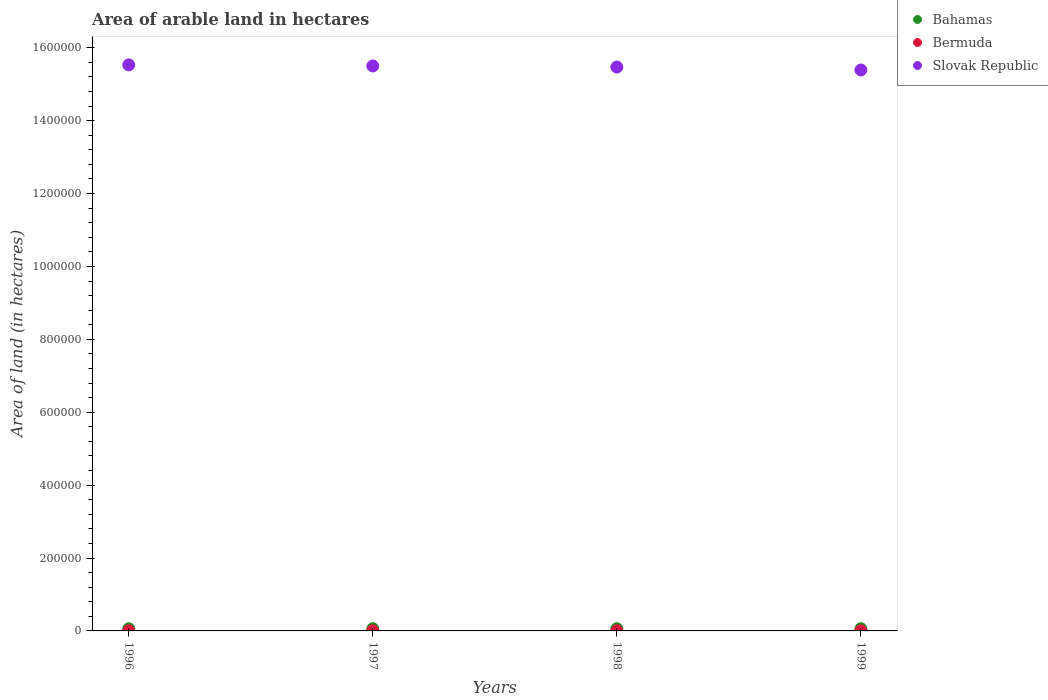What is the total arable land in Bermuda in 1998?
Provide a succinct answer. 400. Across all years, what is the maximum total arable land in Slovak Republic?
Your answer should be compact. 1.55e+06. Across all years, what is the minimum total arable land in Bermuda?
Provide a succinct answer. 400. In which year was the total arable land in Bermuda minimum?
Offer a terse response. 1996. What is the total total arable land in Slovak Republic in the graph?
Provide a succinct answer. 6.19e+06. What is the difference between the total arable land in Slovak Republic in 1996 and that in 1999?
Your answer should be very brief. 1.40e+04. What is the difference between the total arable land in Slovak Republic in 1999 and the total arable land in Bermuda in 1996?
Make the answer very short. 1.54e+06. What is the average total arable land in Bahamas per year?
Provide a short and direct response. 6000. In the year 1997, what is the difference between the total arable land in Slovak Republic and total arable land in Bermuda?
Give a very brief answer. 1.55e+06. What is the ratio of the total arable land in Slovak Republic in 1996 to that in 1997?
Give a very brief answer. 1. Is the total arable land in Bahamas in 1996 less than that in 1999?
Provide a short and direct response. No. Is the difference between the total arable land in Slovak Republic in 1998 and 1999 greater than the difference between the total arable land in Bermuda in 1998 and 1999?
Your answer should be very brief. Yes. What is the difference between the highest and the lowest total arable land in Slovak Republic?
Provide a succinct answer. 1.40e+04. In how many years, is the total arable land in Slovak Republic greater than the average total arable land in Slovak Republic taken over all years?
Provide a short and direct response. 2. Is it the case that in every year, the sum of the total arable land in Bahamas and total arable land in Bermuda  is greater than the total arable land in Slovak Republic?
Your response must be concise. No. Does the total arable land in Bahamas monotonically increase over the years?
Keep it short and to the point. No. Is the total arable land in Bermuda strictly greater than the total arable land in Bahamas over the years?
Ensure brevity in your answer.  No. Is the total arable land in Slovak Republic strictly less than the total arable land in Bermuda over the years?
Make the answer very short. No. How many dotlines are there?
Your answer should be very brief. 3. How many years are there in the graph?
Provide a succinct answer. 4. What is the difference between two consecutive major ticks on the Y-axis?
Ensure brevity in your answer.  2.00e+05. Are the values on the major ticks of Y-axis written in scientific E-notation?
Your answer should be compact. No. Does the graph contain grids?
Your answer should be compact. No. Where does the legend appear in the graph?
Offer a very short reply. Top right. How are the legend labels stacked?
Provide a short and direct response. Vertical. What is the title of the graph?
Provide a succinct answer. Area of arable land in hectares. What is the label or title of the Y-axis?
Provide a short and direct response. Area of land (in hectares). What is the Area of land (in hectares) in Bahamas in 1996?
Provide a succinct answer. 6000. What is the Area of land (in hectares) of Bermuda in 1996?
Keep it short and to the point. 400. What is the Area of land (in hectares) of Slovak Republic in 1996?
Your answer should be compact. 1.55e+06. What is the Area of land (in hectares) of Bahamas in 1997?
Give a very brief answer. 6000. What is the Area of land (in hectares) in Slovak Republic in 1997?
Ensure brevity in your answer.  1.55e+06. What is the Area of land (in hectares) of Bahamas in 1998?
Keep it short and to the point. 6000. What is the Area of land (in hectares) in Slovak Republic in 1998?
Make the answer very short. 1.55e+06. What is the Area of land (in hectares) in Bahamas in 1999?
Keep it short and to the point. 6000. What is the Area of land (in hectares) in Slovak Republic in 1999?
Give a very brief answer. 1.54e+06. Across all years, what is the maximum Area of land (in hectares) of Bahamas?
Provide a succinct answer. 6000. Across all years, what is the maximum Area of land (in hectares) of Bermuda?
Your answer should be compact. 400. Across all years, what is the maximum Area of land (in hectares) of Slovak Republic?
Offer a terse response. 1.55e+06. Across all years, what is the minimum Area of land (in hectares) in Bahamas?
Offer a terse response. 6000. Across all years, what is the minimum Area of land (in hectares) of Bermuda?
Ensure brevity in your answer.  400. Across all years, what is the minimum Area of land (in hectares) of Slovak Republic?
Provide a succinct answer. 1.54e+06. What is the total Area of land (in hectares) of Bahamas in the graph?
Give a very brief answer. 2.40e+04. What is the total Area of land (in hectares) of Bermuda in the graph?
Provide a short and direct response. 1600. What is the total Area of land (in hectares) of Slovak Republic in the graph?
Make the answer very short. 6.19e+06. What is the difference between the Area of land (in hectares) of Bermuda in 1996 and that in 1997?
Provide a succinct answer. 0. What is the difference between the Area of land (in hectares) of Slovak Republic in 1996 and that in 1997?
Ensure brevity in your answer.  3000. What is the difference between the Area of land (in hectares) in Slovak Republic in 1996 and that in 1998?
Keep it short and to the point. 6000. What is the difference between the Area of land (in hectares) of Bermuda in 1996 and that in 1999?
Your response must be concise. 0. What is the difference between the Area of land (in hectares) in Slovak Republic in 1996 and that in 1999?
Offer a terse response. 1.40e+04. What is the difference between the Area of land (in hectares) in Bahamas in 1997 and that in 1998?
Ensure brevity in your answer.  0. What is the difference between the Area of land (in hectares) in Bermuda in 1997 and that in 1998?
Give a very brief answer. 0. What is the difference between the Area of land (in hectares) in Slovak Republic in 1997 and that in 1998?
Your answer should be compact. 3000. What is the difference between the Area of land (in hectares) of Bermuda in 1997 and that in 1999?
Offer a terse response. 0. What is the difference between the Area of land (in hectares) in Slovak Republic in 1997 and that in 1999?
Give a very brief answer. 1.10e+04. What is the difference between the Area of land (in hectares) in Bahamas in 1998 and that in 1999?
Offer a terse response. 0. What is the difference between the Area of land (in hectares) in Bermuda in 1998 and that in 1999?
Offer a terse response. 0. What is the difference between the Area of land (in hectares) of Slovak Republic in 1998 and that in 1999?
Make the answer very short. 8000. What is the difference between the Area of land (in hectares) of Bahamas in 1996 and the Area of land (in hectares) of Bermuda in 1997?
Your response must be concise. 5600. What is the difference between the Area of land (in hectares) of Bahamas in 1996 and the Area of land (in hectares) of Slovak Republic in 1997?
Make the answer very short. -1.54e+06. What is the difference between the Area of land (in hectares) of Bermuda in 1996 and the Area of land (in hectares) of Slovak Republic in 1997?
Provide a short and direct response. -1.55e+06. What is the difference between the Area of land (in hectares) of Bahamas in 1996 and the Area of land (in hectares) of Bermuda in 1998?
Make the answer very short. 5600. What is the difference between the Area of land (in hectares) in Bahamas in 1996 and the Area of land (in hectares) in Slovak Republic in 1998?
Ensure brevity in your answer.  -1.54e+06. What is the difference between the Area of land (in hectares) of Bermuda in 1996 and the Area of land (in hectares) of Slovak Republic in 1998?
Make the answer very short. -1.55e+06. What is the difference between the Area of land (in hectares) in Bahamas in 1996 and the Area of land (in hectares) in Bermuda in 1999?
Your response must be concise. 5600. What is the difference between the Area of land (in hectares) in Bahamas in 1996 and the Area of land (in hectares) in Slovak Republic in 1999?
Keep it short and to the point. -1.53e+06. What is the difference between the Area of land (in hectares) in Bermuda in 1996 and the Area of land (in hectares) in Slovak Republic in 1999?
Ensure brevity in your answer.  -1.54e+06. What is the difference between the Area of land (in hectares) of Bahamas in 1997 and the Area of land (in hectares) of Bermuda in 1998?
Ensure brevity in your answer.  5600. What is the difference between the Area of land (in hectares) of Bahamas in 1997 and the Area of land (in hectares) of Slovak Republic in 1998?
Provide a succinct answer. -1.54e+06. What is the difference between the Area of land (in hectares) of Bermuda in 1997 and the Area of land (in hectares) of Slovak Republic in 1998?
Offer a terse response. -1.55e+06. What is the difference between the Area of land (in hectares) in Bahamas in 1997 and the Area of land (in hectares) in Bermuda in 1999?
Provide a succinct answer. 5600. What is the difference between the Area of land (in hectares) of Bahamas in 1997 and the Area of land (in hectares) of Slovak Republic in 1999?
Your answer should be very brief. -1.53e+06. What is the difference between the Area of land (in hectares) in Bermuda in 1997 and the Area of land (in hectares) in Slovak Republic in 1999?
Offer a very short reply. -1.54e+06. What is the difference between the Area of land (in hectares) in Bahamas in 1998 and the Area of land (in hectares) in Bermuda in 1999?
Provide a short and direct response. 5600. What is the difference between the Area of land (in hectares) in Bahamas in 1998 and the Area of land (in hectares) in Slovak Republic in 1999?
Provide a short and direct response. -1.53e+06. What is the difference between the Area of land (in hectares) of Bermuda in 1998 and the Area of land (in hectares) of Slovak Republic in 1999?
Keep it short and to the point. -1.54e+06. What is the average Area of land (in hectares) of Bahamas per year?
Offer a terse response. 6000. What is the average Area of land (in hectares) in Slovak Republic per year?
Provide a short and direct response. 1.55e+06. In the year 1996, what is the difference between the Area of land (in hectares) of Bahamas and Area of land (in hectares) of Bermuda?
Offer a terse response. 5600. In the year 1996, what is the difference between the Area of land (in hectares) of Bahamas and Area of land (in hectares) of Slovak Republic?
Your answer should be compact. -1.55e+06. In the year 1996, what is the difference between the Area of land (in hectares) in Bermuda and Area of land (in hectares) in Slovak Republic?
Provide a short and direct response. -1.55e+06. In the year 1997, what is the difference between the Area of land (in hectares) in Bahamas and Area of land (in hectares) in Bermuda?
Your response must be concise. 5600. In the year 1997, what is the difference between the Area of land (in hectares) in Bahamas and Area of land (in hectares) in Slovak Republic?
Keep it short and to the point. -1.54e+06. In the year 1997, what is the difference between the Area of land (in hectares) of Bermuda and Area of land (in hectares) of Slovak Republic?
Your answer should be compact. -1.55e+06. In the year 1998, what is the difference between the Area of land (in hectares) of Bahamas and Area of land (in hectares) of Bermuda?
Your answer should be very brief. 5600. In the year 1998, what is the difference between the Area of land (in hectares) in Bahamas and Area of land (in hectares) in Slovak Republic?
Offer a very short reply. -1.54e+06. In the year 1998, what is the difference between the Area of land (in hectares) of Bermuda and Area of land (in hectares) of Slovak Republic?
Make the answer very short. -1.55e+06. In the year 1999, what is the difference between the Area of land (in hectares) of Bahamas and Area of land (in hectares) of Bermuda?
Your answer should be very brief. 5600. In the year 1999, what is the difference between the Area of land (in hectares) of Bahamas and Area of land (in hectares) of Slovak Republic?
Your response must be concise. -1.53e+06. In the year 1999, what is the difference between the Area of land (in hectares) in Bermuda and Area of land (in hectares) in Slovak Republic?
Your response must be concise. -1.54e+06. What is the ratio of the Area of land (in hectares) in Bahamas in 1996 to that in 1997?
Give a very brief answer. 1. What is the ratio of the Area of land (in hectares) in Bermuda in 1996 to that in 1997?
Keep it short and to the point. 1. What is the ratio of the Area of land (in hectares) of Bermuda in 1996 to that in 1998?
Offer a terse response. 1. What is the ratio of the Area of land (in hectares) of Slovak Republic in 1996 to that in 1998?
Your answer should be very brief. 1. What is the ratio of the Area of land (in hectares) of Slovak Republic in 1996 to that in 1999?
Make the answer very short. 1.01. What is the ratio of the Area of land (in hectares) of Bermuda in 1997 to that in 1998?
Give a very brief answer. 1. What is the ratio of the Area of land (in hectares) of Slovak Republic in 1997 to that in 1999?
Your answer should be compact. 1.01. What is the difference between the highest and the second highest Area of land (in hectares) in Bahamas?
Offer a terse response. 0. What is the difference between the highest and the second highest Area of land (in hectares) in Bermuda?
Make the answer very short. 0. What is the difference between the highest and the second highest Area of land (in hectares) in Slovak Republic?
Offer a terse response. 3000. What is the difference between the highest and the lowest Area of land (in hectares) of Slovak Republic?
Your answer should be very brief. 1.40e+04. 